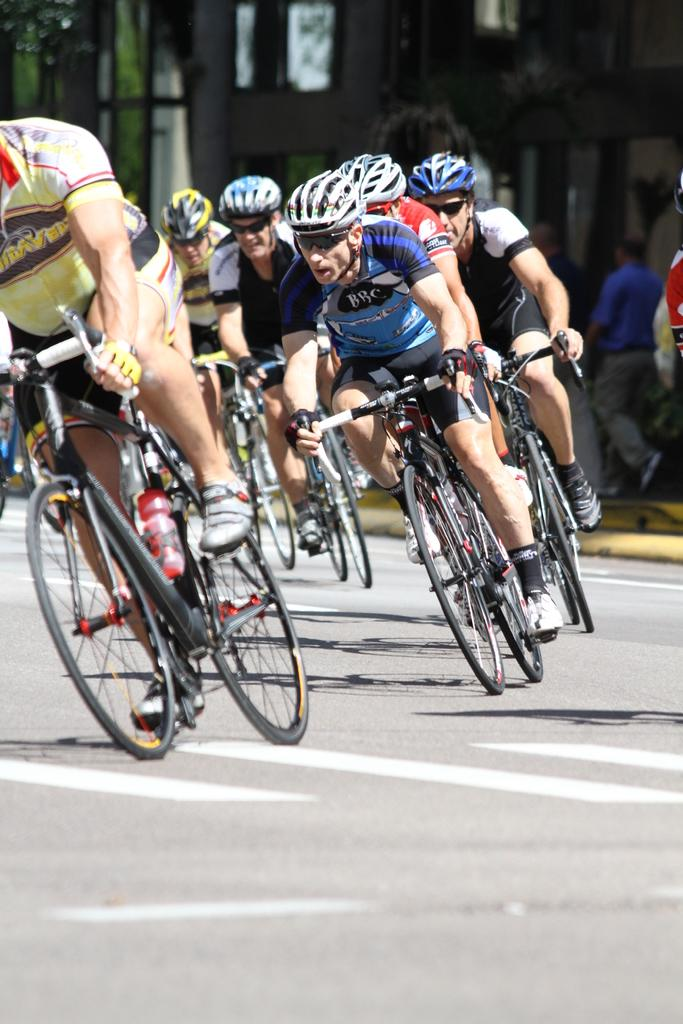What are the men in the image doing? The men in the image are on a cycle. What safety precautions are the men taking? The men are wearing helmets. What additional accessory are the men wearing? The men are wearing shades. What can be seen in the background of the image? There are people in the background of the image, and they are on a path. Can you tell me how many guides are present in the image? There is no mention of guides in the image; it features men on a cycle. What type of tongue can be seen in the image? There is no tongue present in the image. 